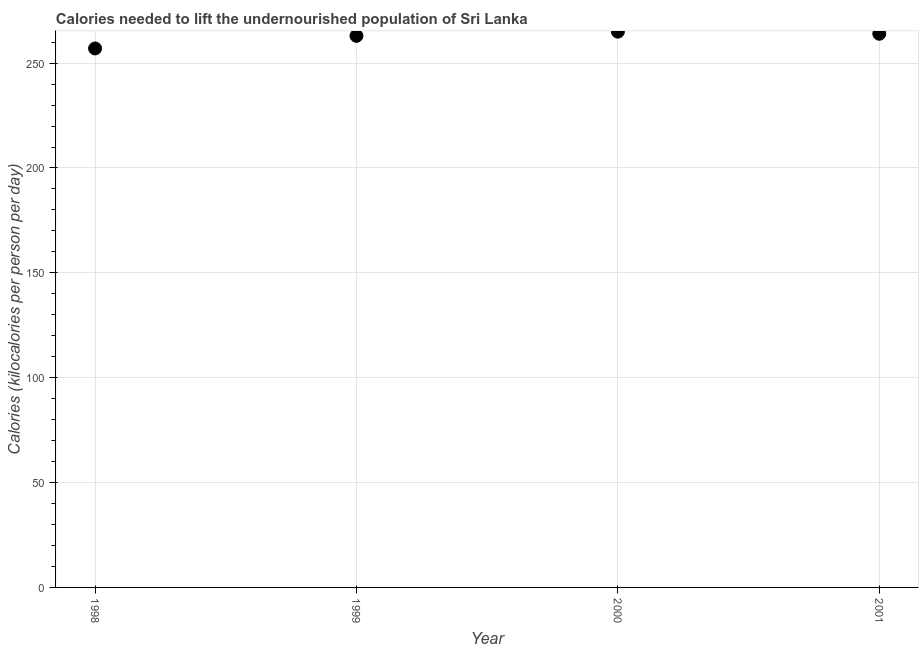What is the depth of food deficit in 1999?
Keep it short and to the point. 263. Across all years, what is the maximum depth of food deficit?
Your answer should be very brief. 265. Across all years, what is the minimum depth of food deficit?
Make the answer very short. 257. In which year was the depth of food deficit maximum?
Offer a terse response. 2000. What is the sum of the depth of food deficit?
Offer a terse response. 1049. What is the difference between the depth of food deficit in 1998 and 2001?
Offer a terse response. -7. What is the average depth of food deficit per year?
Your answer should be very brief. 262.25. What is the median depth of food deficit?
Ensure brevity in your answer.  263.5. In how many years, is the depth of food deficit greater than 160 kilocalories?
Keep it short and to the point. 4. What is the ratio of the depth of food deficit in 1998 to that in 2001?
Give a very brief answer. 0.97. Is the depth of food deficit in 1998 less than that in 2000?
Offer a very short reply. Yes. Is the difference between the depth of food deficit in 1998 and 1999 greater than the difference between any two years?
Offer a very short reply. No. Is the sum of the depth of food deficit in 1998 and 2000 greater than the maximum depth of food deficit across all years?
Give a very brief answer. Yes. What is the difference between the highest and the lowest depth of food deficit?
Offer a terse response. 8. Does the depth of food deficit monotonically increase over the years?
Keep it short and to the point. No. How many years are there in the graph?
Your response must be concise. 4. What is the difference between two consecutive major ticks on the Y-axis?
Keep it short and to the point. 50. Does the graph contain any zero values?
Offer a terse response. No. What is the title of the graph?
Your response must be concise. Calories needed to lift the undernourished population of Sri Lanka. What is the label or title of the Y-axis?
Provide a short and direct response. Calories (kilocalories per person per day). What is the Calories (kilocalories per person per day) in 1998?
Keep it short and to the point. 257. What is the Calories (kilocalories per person per day) in 1999?
Give a very brief answer. 263. What is the Calories (kilocalories per person per day) in 2000?
Keep it short and to the point. 265. What is the Calories (kilocalories per person per day) in 2001?
Offer a very short reply. 264. What is the difference between the Calories (kilocalories per person per day) in 1998 and 1999?
Provide a short and direct response. -6. What is the difference between the Calories (kilocalories per person per day) in 1998 and 2000?
Your response must be concise. -8. What is the difference between the Calories (kilocalories per person per day) in 1999 and 2000?
Offer a very short reply. -2. What is the difference between the Calories (kilocalories per person per day) in 2000 and 2001?
Provide a short and direct response. 1. What is the ratio of the Calories (kilocalories per person per day) in 1998 to that in 1999?
Make the answer very short. 0.98. What is the ratio of the Calories (kilocalories per person per day) in 1998 to that in 2001?
Provide a succinct answer. 0.97. 